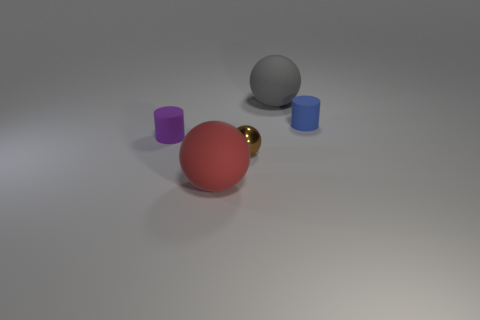Add 4 large blue cubes. How many objects exist? 9 Subtract all spheres. How many objects are left? 2 Add 4 gray rubber things. How many gray rubber things are left? 5 Add 4 red rubber balls. How many red rubber balls exist? 5 Subtract 0 green cubes. How many objects are left? 5 Subtract all large red matte objects. Subtract all tiny spheres. How many objects are left? 3 